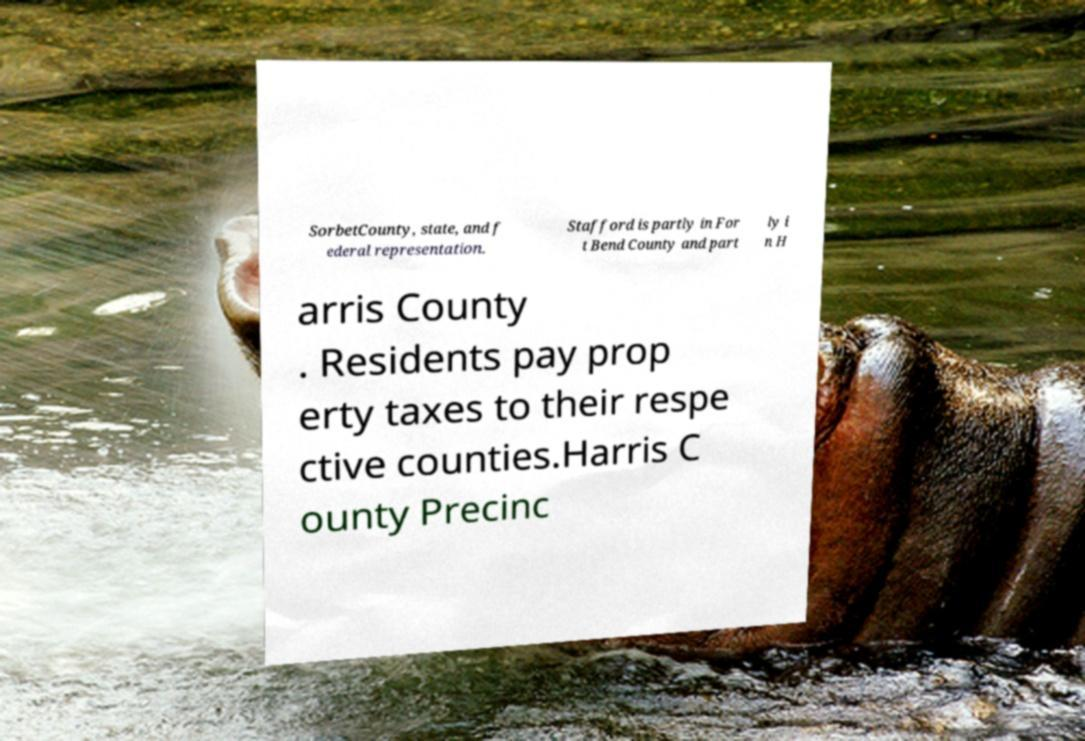For documentation purposes, I need the text within this image transcribed. Could you provide that? SorbetCounty, state, and f ederal representation. Stafford is partly in For t Bend County and part ly i n H arris County . Residents pay prop erty taxes to their respe ctive counties.Harris C ounty Precinc 